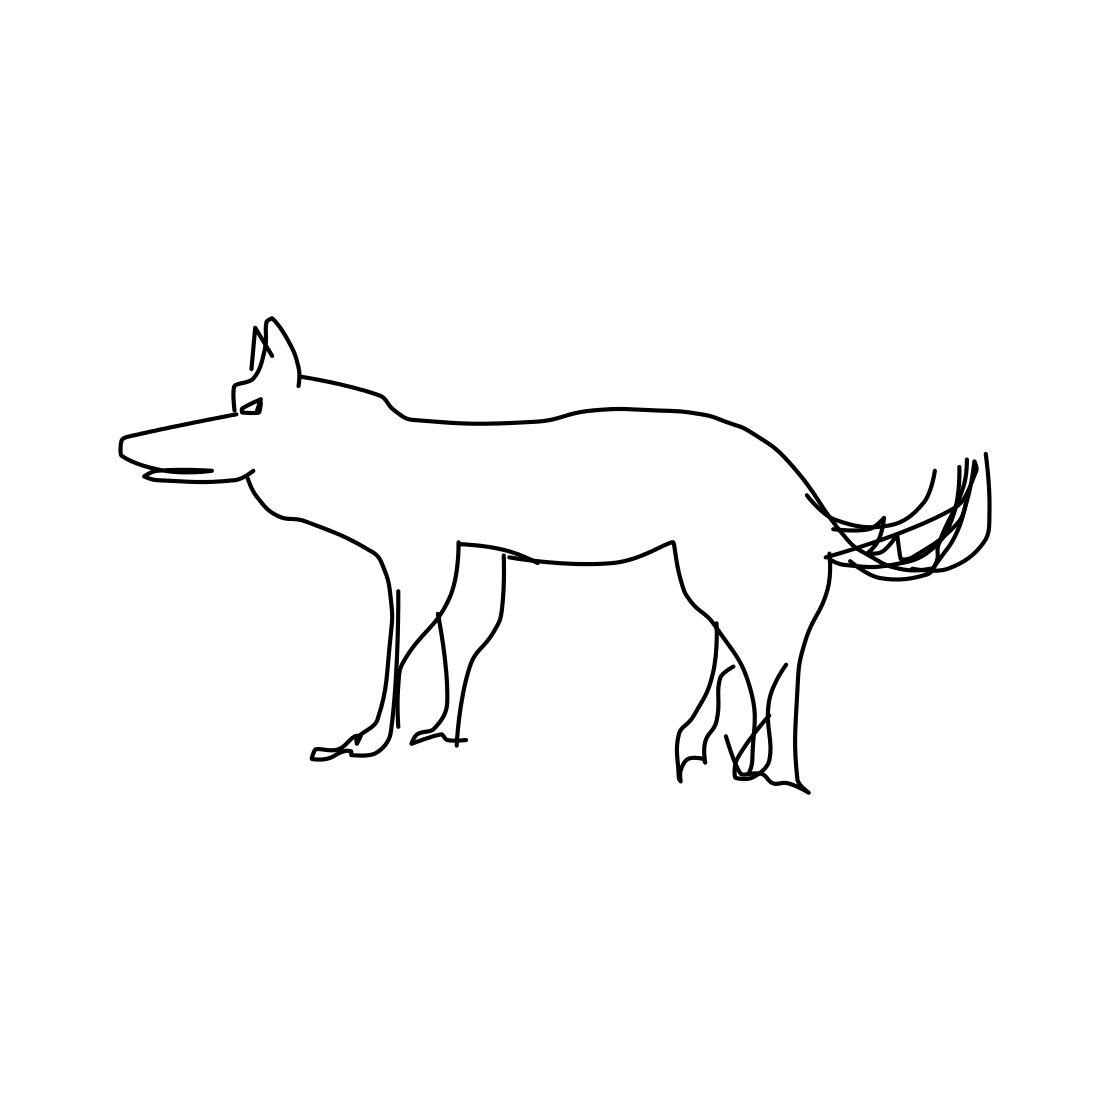Could this drawing be part of a larger story or narrative? Absolutely, this drawing could serve as a visual element in a storybook or a conceptual sketch for a character. It has the potential to be an integral part of a narrative, perhaps depicting a loyal companion on an adventure or a solitary figure on a journey. What could this dog possibly represent in such a narrative? In a narrative, the dog could symbolize a variety of themes such as loyalty, courage, or friendship. It might represent a character's faithful sidekick or a metaphor for the journey itself, embodying endurance and steadfastness. 